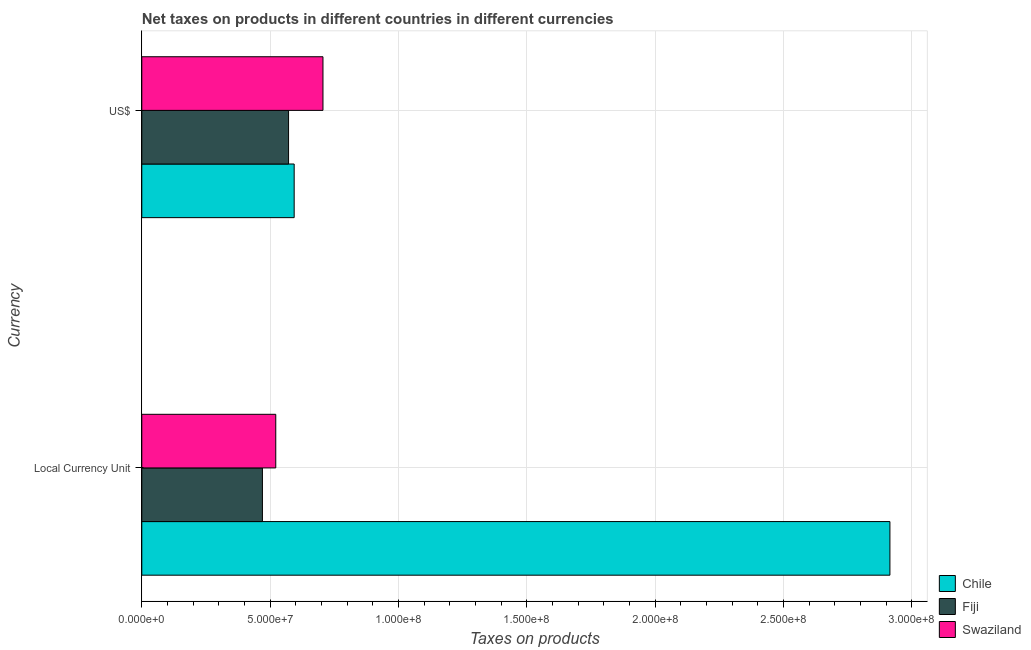How many different coloured bars are there?
Provide a short and direct response. 3. How many groups of bars are there?
Ensure brevity in your answer.  2. Are the number of bars per tick equal to the number of legend labels?
Provide a short and direct response. Yes. Are the number of bars on each tick of the Y-axis equal?
Your response must be concise. Yes. What is the label of the 2nd group of bars from the top?
Your answer should be compact. Local Currency Unit. What is the net taxes in constant 2005 us$ in Swaziland?
Your answer should be compact. 5.22e+07. Across all countries, what is the maximum net taxes in us$?
Offer a terse response. 7.06e+07. Across all countries, what is the minimum net taxes in constant 2005 us$?
Provide a succinct answer. 4.70e+07. In which country was the net taxes in constant 2005 us$ maximum?
Keep it short and to the point. Chile. In which country was the net taxes in us$ minimum?
Give a very brief answer. Fiji. What is the total net taxes in us$ in the graph?
Keep it short and to the point. 1.87e+08. What is the difference between the net taxes in constant 2005 us$ in Fiji and that in Chile?
Your answer should be very brief. -2.44e+08. What is the difference between the net taxes in us$ in Chile and the net taxes in constant 2005 us$ in Swaziland?
Ensure brevity in your answer.  7.17e+06. What is the average net taxes in constant 2005 us$ per country?
Your response must be concise. 1.30e+08. What is the difference between the net taxes in constant 2005 us$ and net taxes in us$ in Swaziland?
Provide a succinct answer. -1.84e+07. What is the ratio of the net taxes in constant 2005 us$ in Swaziland to that in Fiji?
Keep it short and to the point. 1.11. Is the net taxes in constant 2005 us$ in Swaziland less than that in Fiji?
Make the answer very short. No. In how many countries, is the net taxes in constant 2005 us$ greater than the average net taxes in constant 2005 us$ taken over all countries?
Provide a succinct answer. 1. What does the 1st bar from the top in US$ represents?
Your answer should be very brief. Swaziland. What does the 2nd bar from the bottom in US$ represents?
Your answer should be compact. Fiji. How many bars are there?
Your answer should be very brief. 6. How many countries are there in the graph?
Offer a very short reply. 3. Does the graph contain any zero values?
Your answer should be compact. No. How many legend labels are there?
Make the answer very short. 3. How are the legend labels stacked?
Your response must be concise. Vertical. What is the title of the graph?
Keep it short and to the point. Net taxes on products in different countries in different currencies. What is the label or title of the X-axis?
Provide a succinct answer. Taxes on products. What is the label or title of the Y-axis?
Provide a short and direct response. Currency. What is the Taxes on products in Chile in Local Currency Unit?
Your response must be concise. 2.92e+08. What is the Taxes on products in Fiji in Local Currency Unit?
Your response must be concise. 4.70e+07. What is the Taxes on products of Swaziland in Local Currency Unit?
Give a very brief answer. 5.22e+07. What is the Taxes on products of Chile in US$?
Your answer should be very brief. 5.94e+07. What is the Taxes on products of Fiji in US$?
Provide a succinct answer. 5.72e+07. What is the Taxes on products in Swaziland in US$?
Your response must be concise. 7.06e+07. Across all Currency, what is the maximum Taxes on products of Chile?
Ensure brevity in your answer.  2.92e+08. Across all Currency, what is the maximum Taxes on products of Fiji?
Provide a succinct answer. 5.72e+07. Across all Currency, what is the maximum Taxes on products of Swaziland?
Provide a short and direct response. 7.06e+07. Across all Currency, what is the minimum Taxes on products in Chile?
Ensure brevity in your answer.  5.94e+07. Across all Currency, what is the minimum Taxes on products of Fiji?
Give a very brief answer. 4.70e+07. Across all Currency, what is the minimum Taxes on products of Swaziland?
Keep it short and to the point. 5.22e+07. What is the total Taxes on products in Chile in the graph?
Keep it short and to the point. 3.51e+08. What is the total Taxes on products in Fiji in the graph?
Provide a succinct answer. 1.04e+08. What is the total Taxes on products in Swaziland in the graph?
Ensure brevity in your answer.  1.23e+08. What is the difference between the Taxes on products in Chile in Local Currency Unit and that in US$?
Your answer should be compact. 2.32e+08. What is the difference between the Taxes on products in Fiji in Local Currency Unit and that in US$?
Make the answer very short. -1.02e+07. What is the difference between the Taxes on products of Swaziland in Local Currency Unit and that in US$?
Give a very brief answer. -1.84e+07. What is the difference between the Taxes on products in Chile in Local Currency Unit and the Taxes on products in Fiji in US$?
Offer a terse response. 2.34e+08. What is the difference between the Taxes on products of Chile in Local Currency Unit and the Taxes on products of Swaziland in US$?
Your answer should be compact. 2.21e+08. What is the difference between the Taxes on products in Fiji in Local Currency Unit and the Taxes on products in Swaziland in US$?
Your answer should be compact. -2.36e+07. What is the average Taxes on products in Chile per Currency?
Your answer should be very brief. 1.75e+08. What is the average Taxes on products of Fiji per Currency?
Keep it short and to the point. 5.21e+07. What is the average Taxes on products of Swaziland per Currency?
Ensure brevity in your answer.  6.14e+07. What is the difference between the Taxes on products in Chile and Taxes on products in Fiji in Local Currency Unit?
Give a very brief answer. 2.44e+08. What is the difference between the Taxes on products of Chile and Taxes on products of Swaziland in Local Currency Unit?
Make the answer very short. 2.39e+08. What is the difference between the Taxes on products of Fiji and Taxes on products of Swaziland in Local Currency Unit?
Keep it short and to the point. -5.20e+06. What is the difference between the Taxes on products in Chile and Taxes on products in Fiji in US$?
Keep it short and to the point. 2.18e+06. What is the difference between the Taxes on products of Chile and Taxes on products of Swaziland in US$?
Provide a short and direct response. -1.12e+07. What is the difference between the Taxes on products in Fiji and Taxes on products in Swaziland in US$?
Keep it short and to the point. -1.34e+07. What is the ratio of the Taxes on products of Chile in Local Currency Unit to that in US$?
Your response must be concise. 4.91. What is the ratio of the Taxes on products of Fiji in Local Currency Unit to that in US$?
Your answer should be very brief. 0.82. What is the ratio of the Taxes on products of Swaziland in Local Currency Unit to that in US$?
Give a very brief answer. 0.74. What is the difference between the highest and the second highest Taxes on products in Chile?
Your answer should be very brief. 2.32e+08. What is the difference between the highest and the second highest Taxes on products of Fiji?
Your answer should be very brief. 1.02e+07. What is the difference between the highest and the second highest Taxes on products of Swaziland?
Your answer should be very brief. 1.84e+07. What is the difference between the highest and the lowest Taxes on products in Chile?
Provide a succinct answer. 2.32e+08. What is the difference between the highest and the lowest Taxes on products of Fiji?
Your answer should be compact. 1.02e+07. What is the difference between the highest and the lowest Taxes on products of Swaziland?
Make the answer very short. 1.84e+07. 